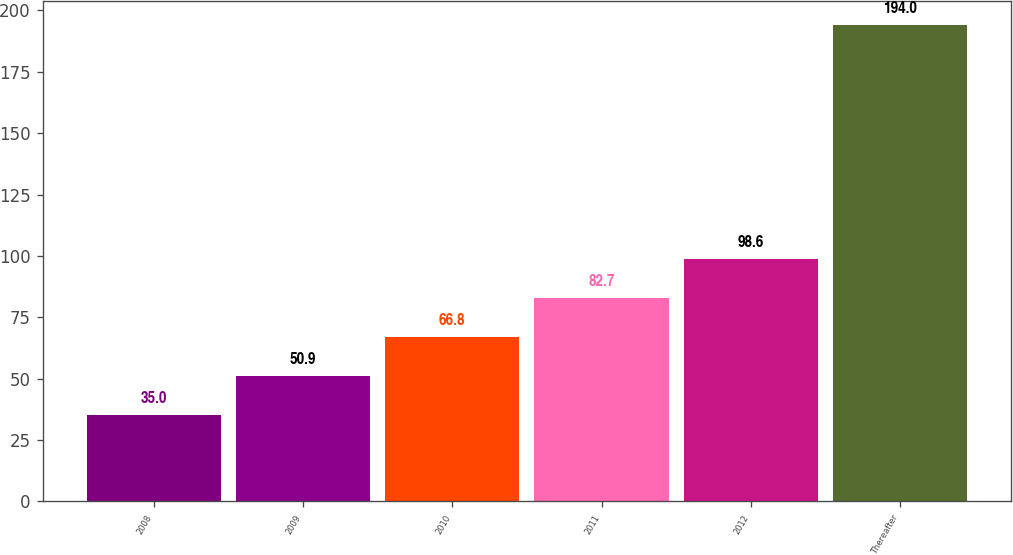Convert chart. <chart><loc_0><loc_0><loc_500><loc_500><bar_chart><fcel>2008<fcel>2009<fcel>2010<fcel>2011<fcel>2012<fcel>Thereafter<nl><fcel>35<fcel>50.9<fcel>66.8<fcel>82.7<fcel>98.6<fcel>194<nl></chart> 